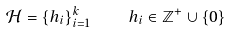<formula> <loc_0><loc_0><loc_500><loc_500>\mathcal { H } = \{ h _ { i } \} ^ { k } _ { i = 1 } \quad h _ { i } \in \mathbb { Z } ^ { + } \cup \{ 0 \}</formula> 